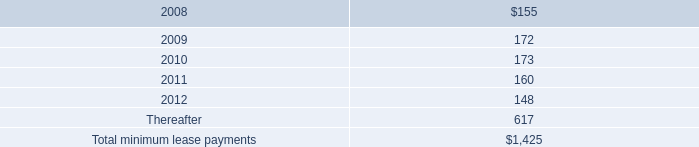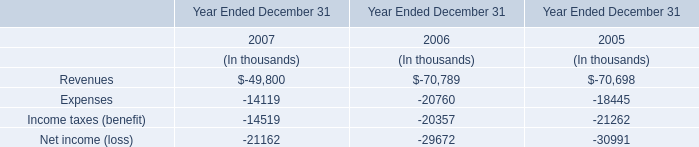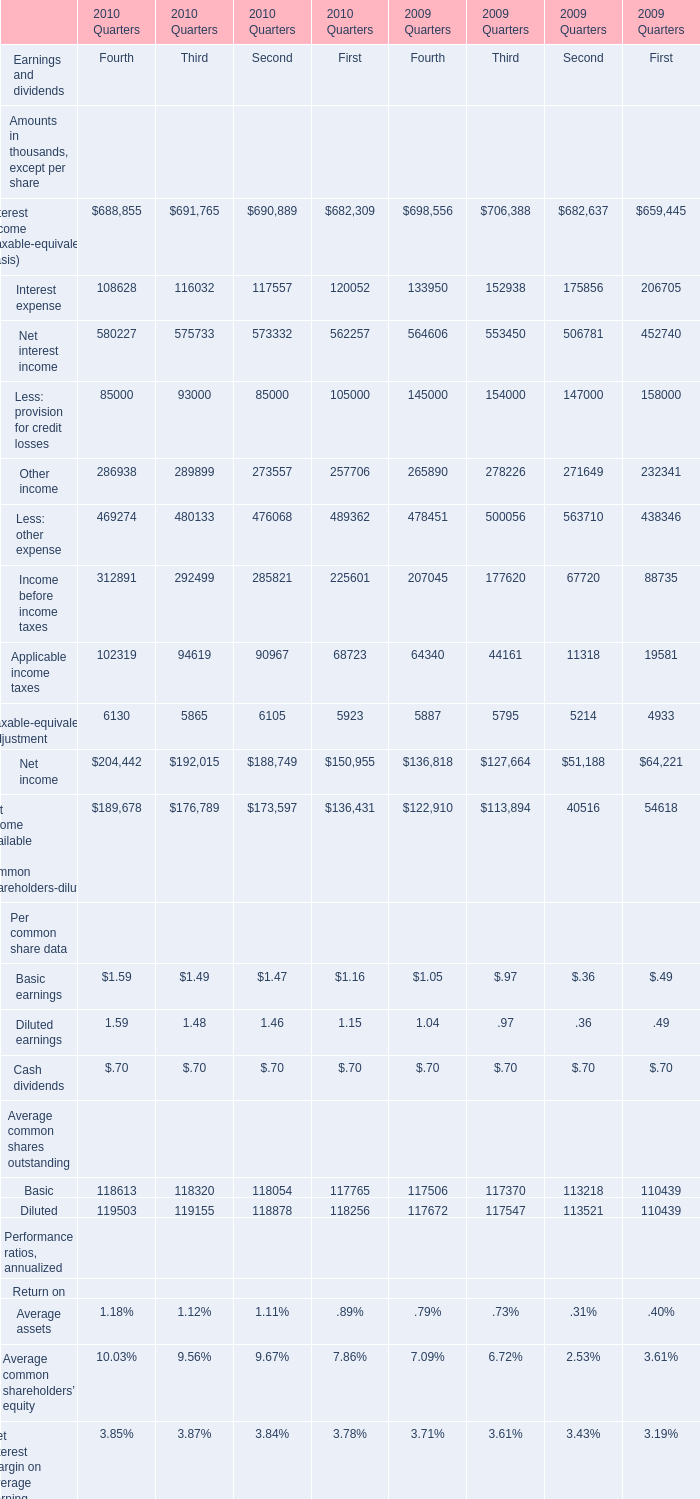At end of the second quarter of 2009, what is the value of Deposits? (in million) 
Answer: 46755. 